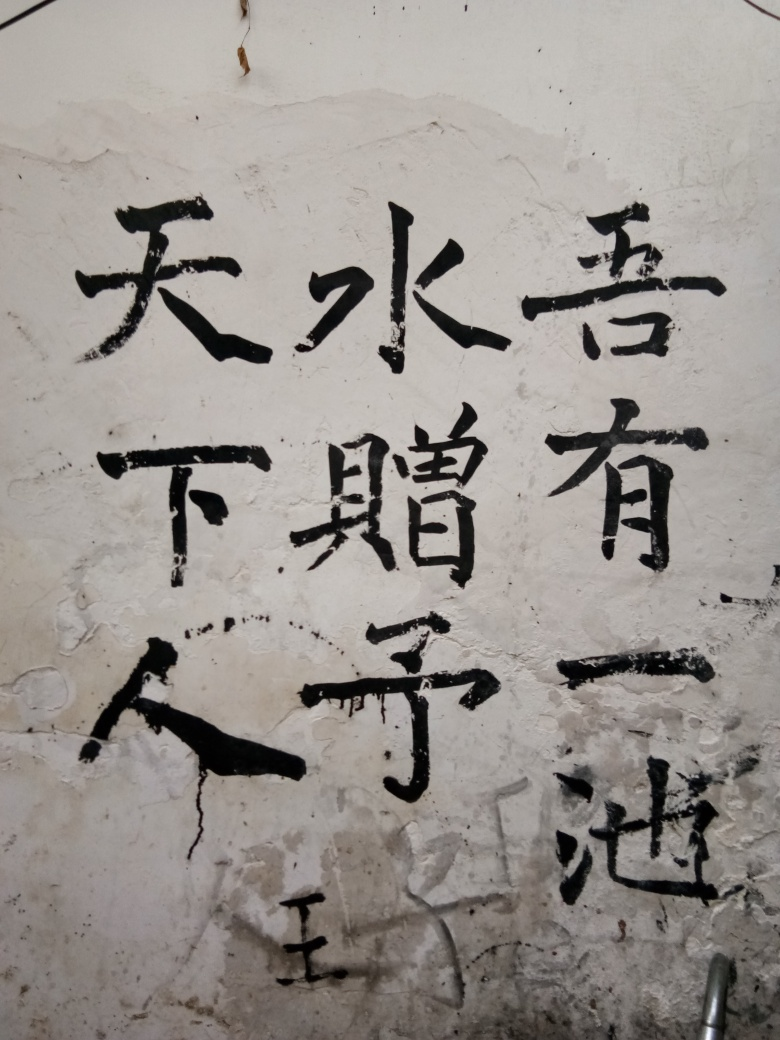Can you tell me what these Chinese characters mean? These characters are traditional Chinese script, often used in formal documents, artistic works, or as a stylistic choice. To provide a translation or interpretation, knowledge of the language and context would be necessary. 